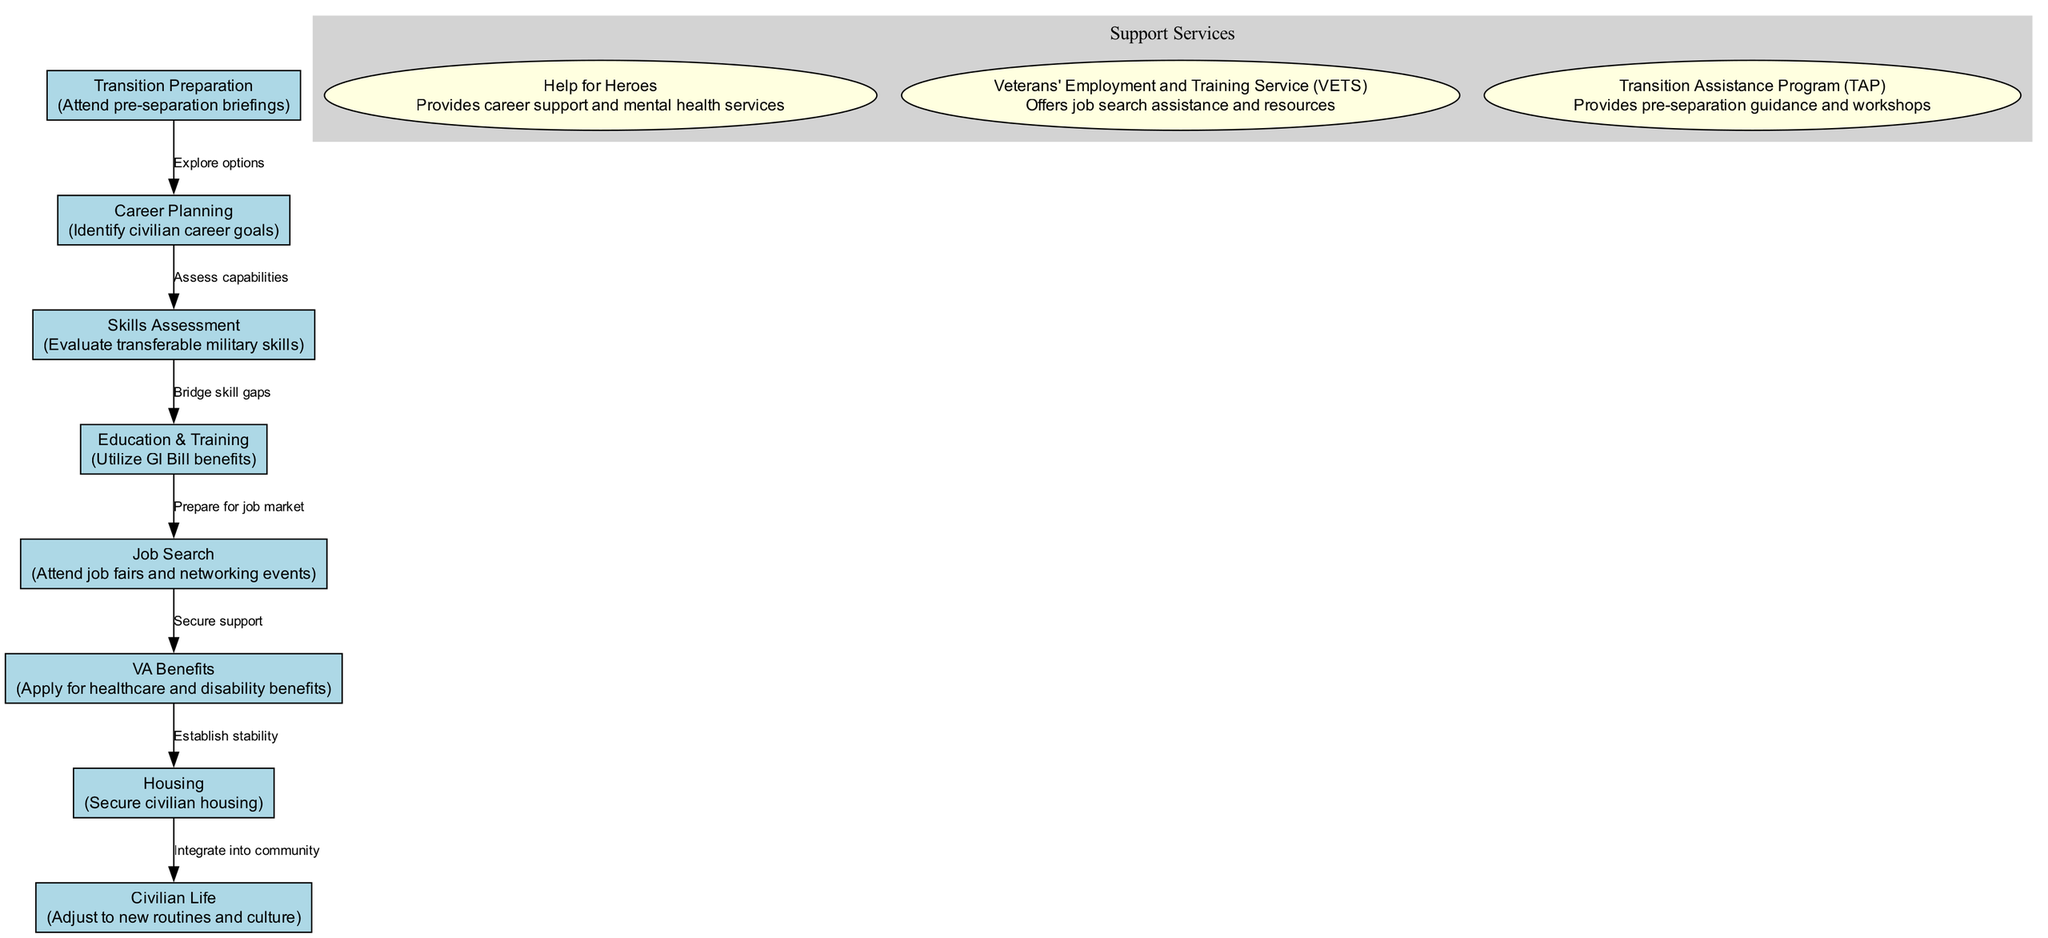What is the first step in the transition process? The diagram indicates the first step as "Transition Preparation," which is highlighted in the specified node.
Answer: Transition Preparation How many support services are listed in the diagram? By counting the nodes within the "Support Services" cluster, we can see there are three services mentioned: Help for Heroes, Veterans' Employment and Training Service (VETS), and Transition Assistance Program (TAP).
Answer: 3 What is the purpose of the "Education & Training" step? The node labeled "Education & Training" specifies the purpose as "Utilize GI Bill benefits," which is directly mentioned in the details of that node.
Answer: Utilize GI Bill benefits Which step follows "Job Search"? In the diagram, the flow moves from "Job Search" to "VA Benefits," characterized by the edge connecting these two nodes.
Answer: VA Benefits What is the relationship between "Skills Assessment" and "Education & Training"? The edge from "Skills Assessment" to "Education & Training" indicates the process of "Bridge skill gaps," suggesting that skills assessment is necessary before pursuing education and training.
Answer: Bridge skill gaps What is the last step in the transition process? The end node of the flowchart is "Civilian Life," marking the culmination of the transition process and adjustment to new routines.
Answer: Civilian Life What does the "Job Search" step emphasize? The details within the "Job Search" node state that it focuses on attending job fairs and networking events, outlining critical activities undertaken during this transition period.
Answer: Attend job fairs and networking events Which support service focuses on job search assistance? Among the listed support services, the "Veterans' Employment and Training Service (VETS)" explicitly offers job search assistance and resources, as per the service's role described in the diagram.
Answer: Veterans' Employment and Training Service (VETS) 